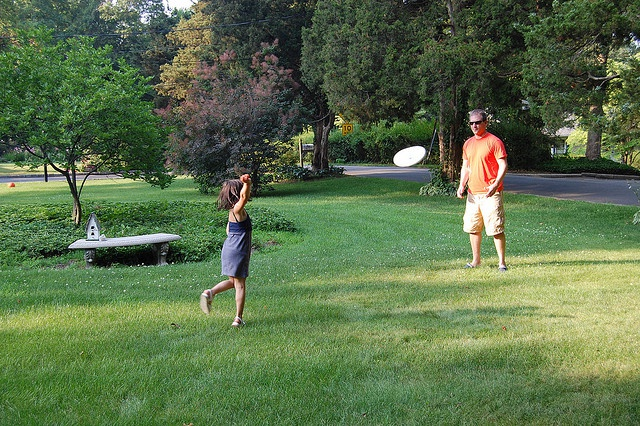Describe the objects in this image and their specific colors. I can see people in darkgreen, white, tan, salmon, and red tones, people in darkgreen, black, maroon, gray, and darkgray tones, bench in darkgreen, lavender, black, gray, and darkgray tones, and frisbee in darkgreen, white, darkgray, black, and gray tones in this image. 